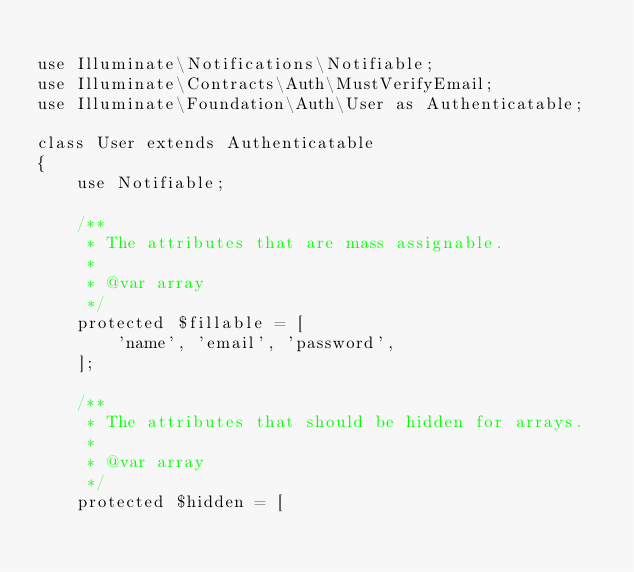Convert code to text. <code><loc_0><loc_0><loc_500><loc_500><_PHP_>
use Illuminate\Notifications\Notifiable;
use Illuminate\Contracts\Auth\MustVerifyEmail;
use Illuminate\Foundation\Auth\User as Authenticatable;

class User extends Authenticatable
{
    use Notifiable;

    /**
     * The attributes that are mass assignable.
     *
     * @var array
     */
    protected $fillable = [
        'name', 'email', 'password',
    ];

    /**
     * The attributes that should be hidden for arrays.
     *
     * @var array
     */
    protected $hidden = [</code> 